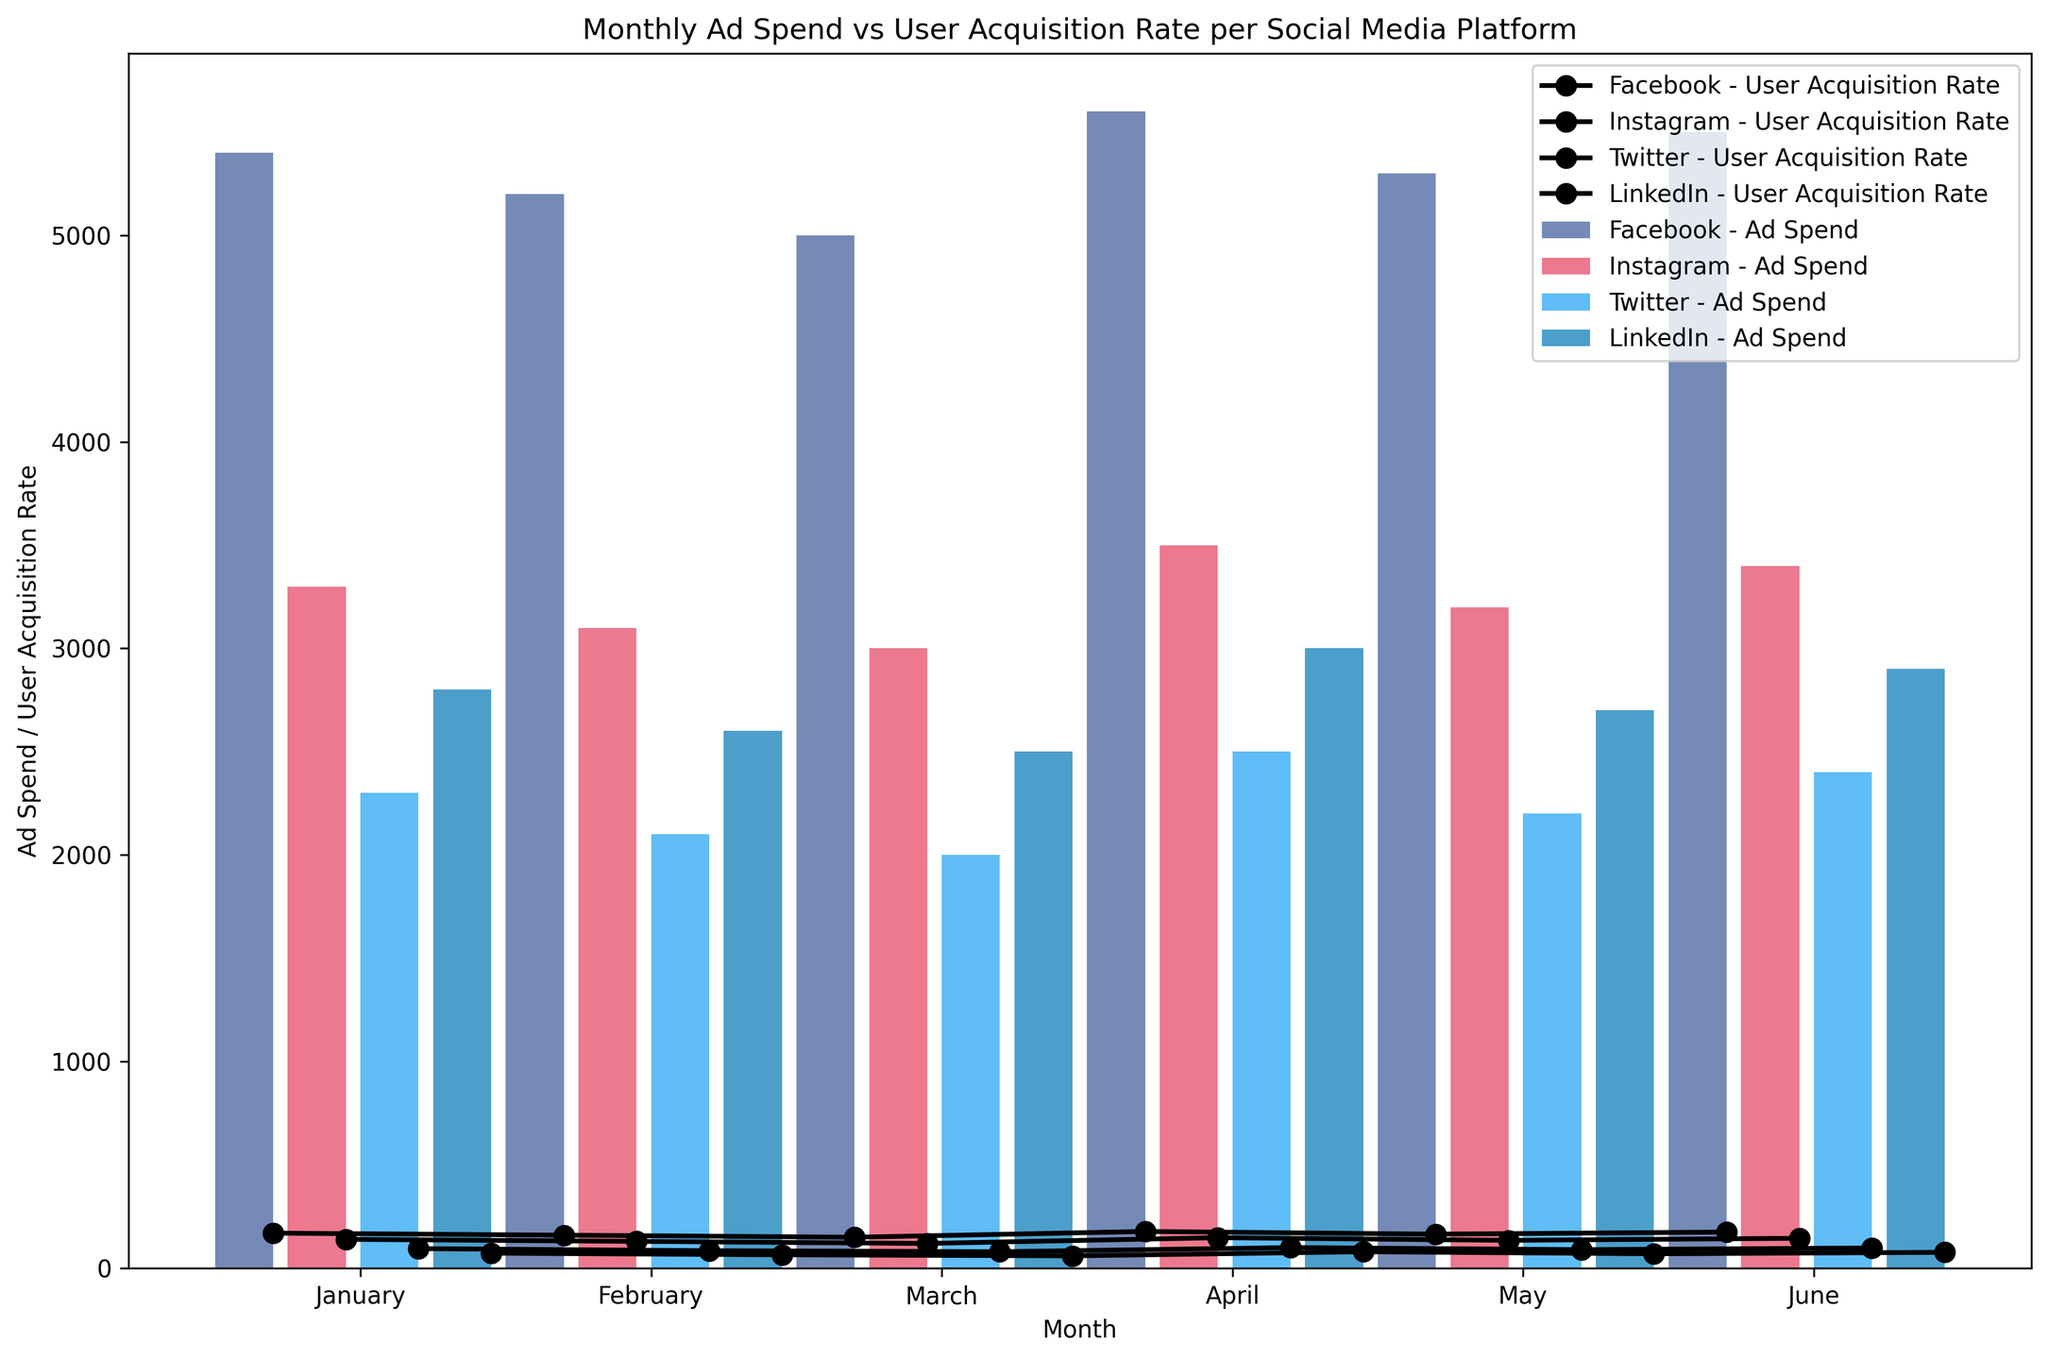What is the month with the highest ad spend for Facebook? To find the month with the highest ad spend for Facebook, look for the tallest bar in Facebook’s color (blue). The bar corresponding to June is the highest.
Answer: June Which platform had the highest user acquisition rate in March? Identify the platform in March with the highest point marker (circle), which indicates user acquisition rate. This is Facebook (blue), as it has the highest point marker in March.
Answer: Facebook What is the total ad spend for Twitter across all months? To find the total ad spend for Twitter, sum the heights of the bars for Twitter (light blue). The values are 2000 + 2100 + 2200 + 2300 + 2400 + 2500. Summing these, the total is 13500.
Answer: 13500 Which platform had the most consistent ad spend over the months? Check for the platform whose bars are the most uniform in height over the months. LinkedIn (blue) appears to have the most evenly distributed ad spend over the months.
Answer: LinkedIn By how much did Instagram's user acquisition rate increase from January to June? Locate the points on the chart for Instagram (light red) in January and June. The user acquisition rate in January is 120, and in June, it is 148. The increase is 148 - 120 = 28.
Answer: 28 Which month saw the highest combined user acquisition rate across all platforms? Sum the user acquisition rates (points) for all platforms for each month. The month with the highest sum is the one with the highest combined user acquisition rate. This is June, with the highest aggregate point heights.
Answer: June Which platform had the smallest difference between its highest and lowest user acquisition rate? Calculate the difference between the highest and lowest user acquisition rates (points) for each platform. LinkedIn (blue) had the smallest range with the highest at 80 and the lowest at 60, giving a difference of 20.
Answer: LinkedIn Was there any month where Facebook's user acquisition rate decreased compared to the previous month? Compare the position of Facebook’s points from one month to the next. Each month shows an increase (the points consistently rise), so no month had a decrease.
Answer: No Across all platforms, what is the average ad spend in April? Add the ad spend values for April for all platforms (5400 + 3300 + 2300 + 2800). Then divide by the number of platforms (4). The total is 13800, and the average is 13800 / 4 = 3450.
Answer: 3450 